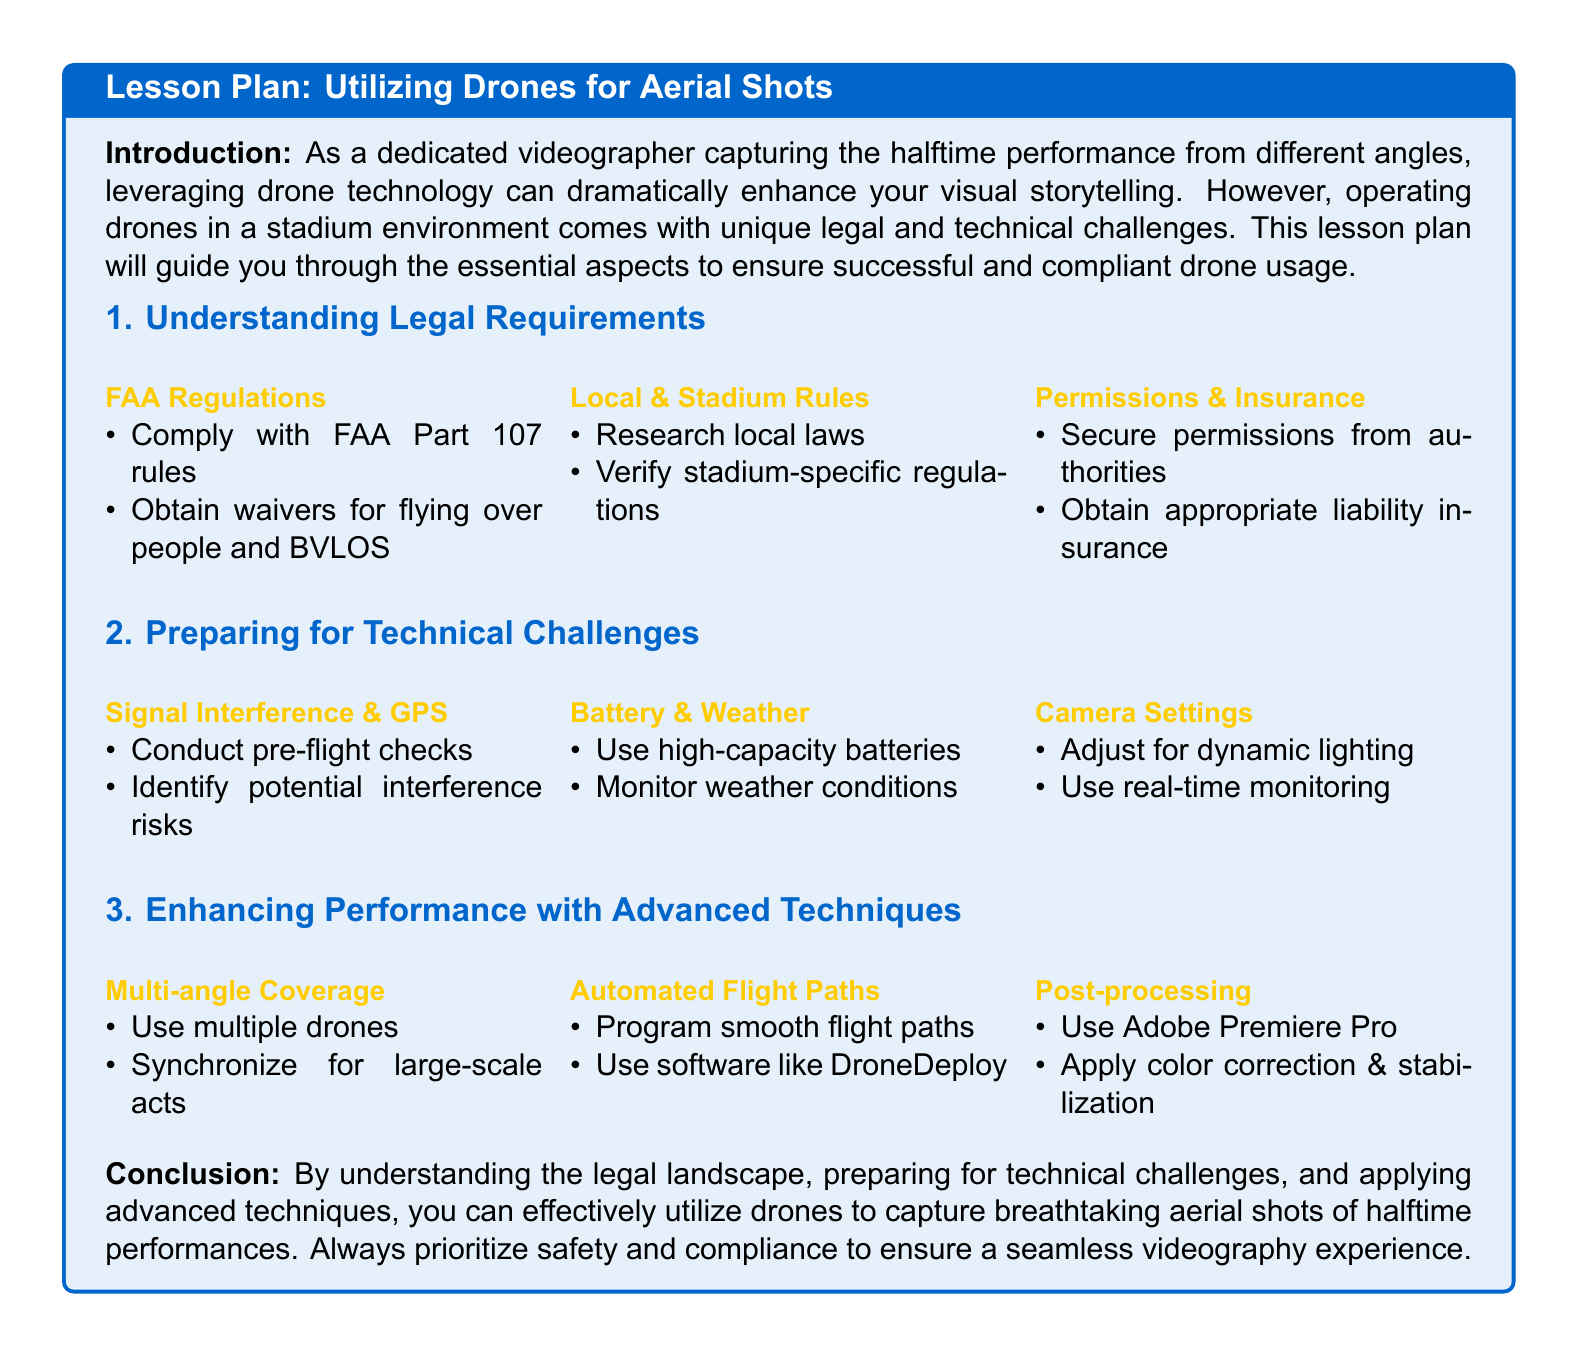what regulations must be complied with when using drones? The document specifies that one must comply with FAA Part 107 rules.
Answer: FAA Part 107 what kind of insurance is recommended? The recommended insurance type mentioned is appropriate liability insurance.
Answer: liability insurance what is a key pre-flight check mentioned in the document? A key pre-flight check includes identifying potential interference risks.
Answer: potential interference risks which software can be used to program smooth flight paths? The document suggests using software like DroneDeploy for programming smooth flight paths.
Answer: DroneDeploy what technique can enhance performance using multiple drones? The technique mentioned is to synchronize for large-scale acts.
Answer: synchronize for large-scale acts what video editing software is recommended for post-processing? The recommended video editing software mentioned is Adobe Premiere Pro.
Answer: Adobe Premiere Pro how many areas are outlined for preparing for technical challenges? The document outlines three areas for preparing for technical challenges.
Answer: three what should be monitored along with battery capacity? Weather conditions should be monitored alongside battery capacity.
Answer: weather conditions what is the main focus of the lesson plan? The main focus of the lesson plan is utilizing drones for aerial shots while ensuring compliance and safety.
Answer: utilizing drones for aerial shots 